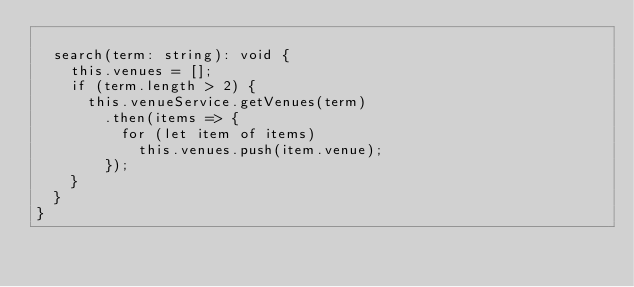<code> <loc_0><loc_0><loc_500><loc_500><_TypeScript_>
  search(term: string): void {
    this.venues = [];
    if (term.length > 2) {
      this.venueService.getVenues(term)
        .then(items => {
          for (let item of items)
            this.venues.push(item.venue);
        });
    }
  }
}

</code> 